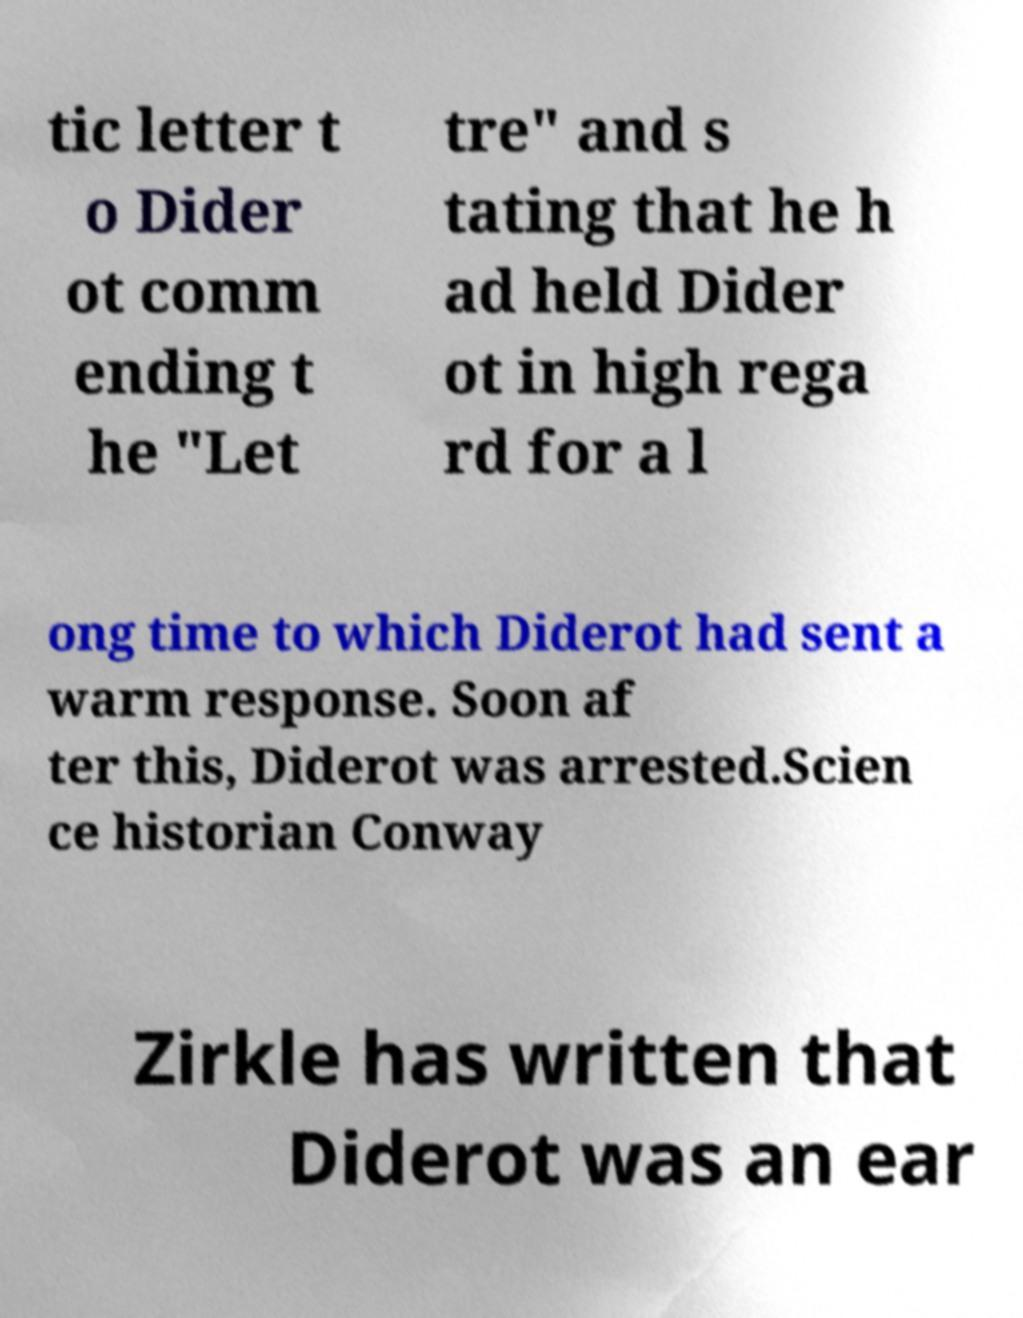Can you read and provide the text displayed in the image?This photo seems to have some interesting text. Can you extract and type it out for me? tic letter t o Dider ot comm ending t he "Let tre" and s tating that he h ad held Dider ot in high rega rd for a l ong time to which Diderot had sent a warm response. Soon af ter this, Diderot was arrested.Scien ce historian Conway Zirkle has written that Diderot was an ear 